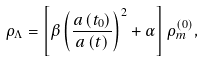<formula> <loc_0><loc_0><loc_500><loc_500>\rho _ { \Lambda } = \left [ \beta \left ( \frac { a \left ( t _ { 0 } \right ) } { a \left ( t \right ) } \right ) ^ { 2 } + \alpha \right ] \rho _ { m } ^ { \left ( 0 \right ) } ,</formula> 